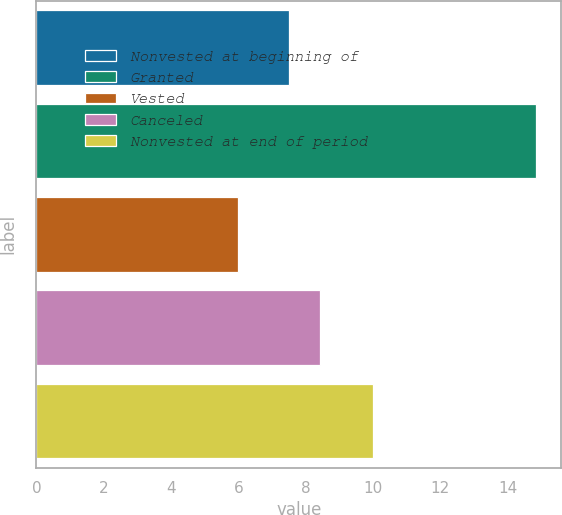<chart> <loc_0><loc_0><loc_500><loc_500><bar_chart><fcel>Nonvested at beginning of<fcel>Granted<fcel>Vested<fcel>Canceled<fcel>Nonvested at end of period<nl><fcel>7.52<fcel>14.85<fcel>5.99<fcel>8.42<fcel>9.99<nl></chart> 